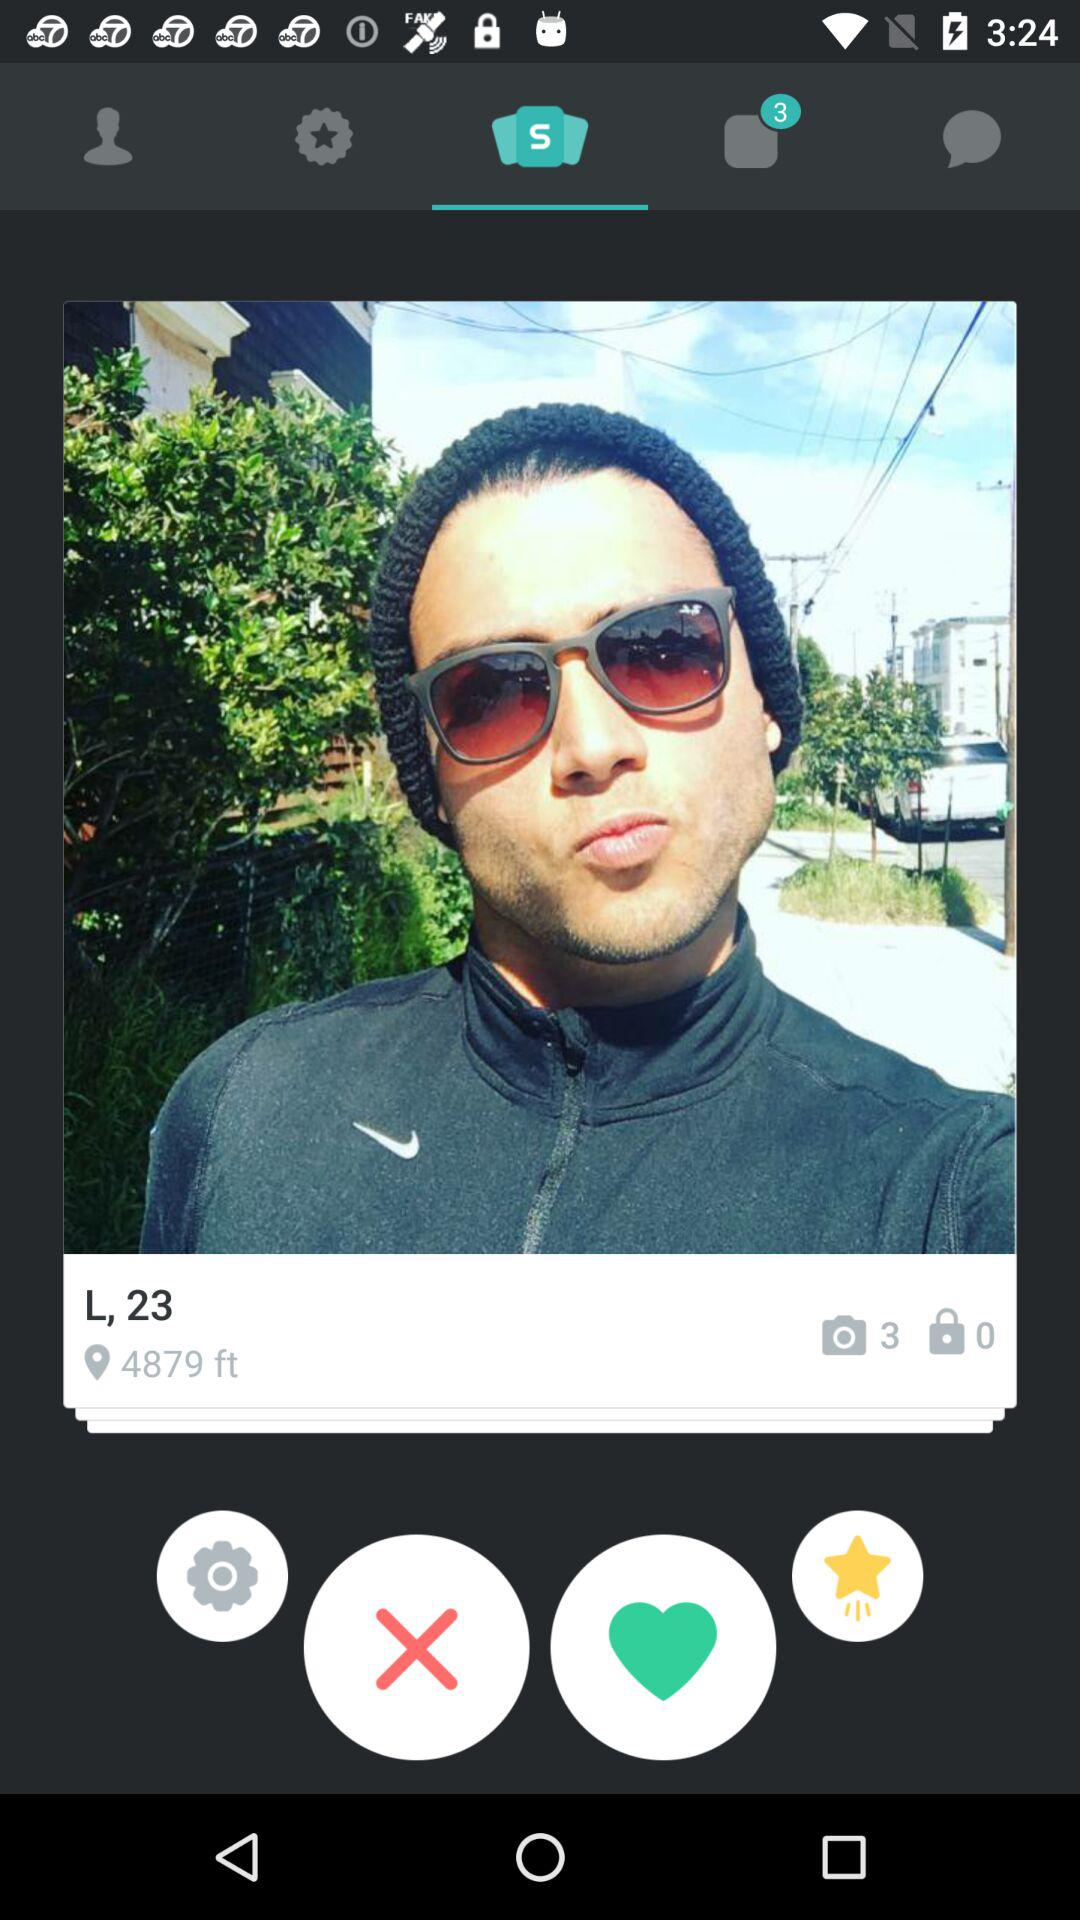What is the name of the application?
When the provided information is insufficient, respond with <no answer>. <no answer> 